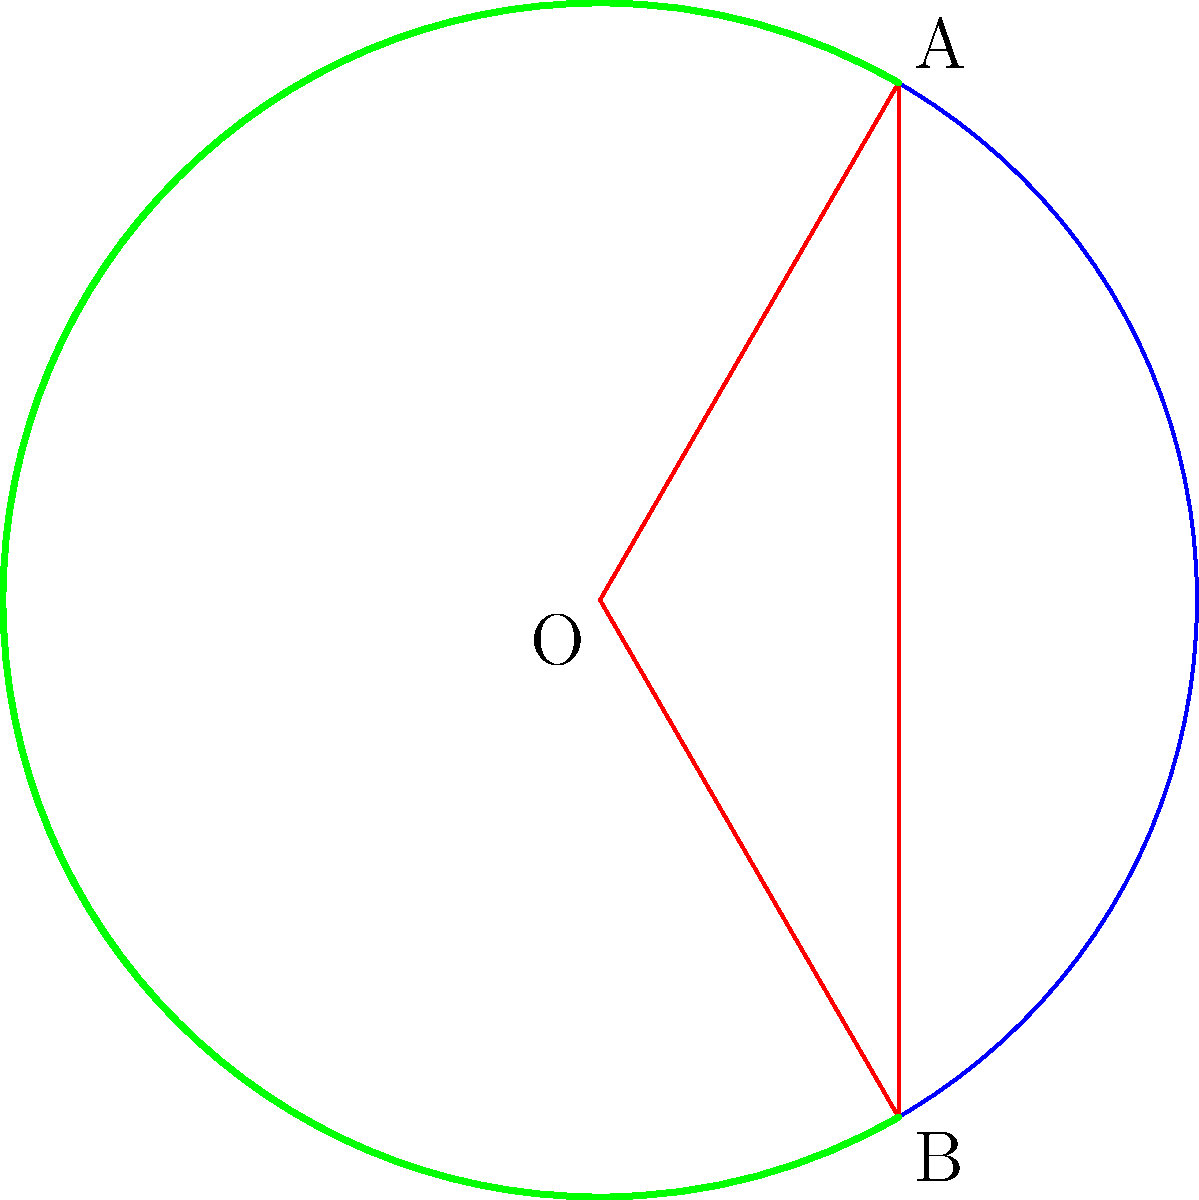In early periodic tables, elements were often arranged in circular segments. Consider a circular representation where a segment spans an angle of 120°. If the radius of the circle is 10 cm, what is the area of this segment in square centimeters? Round your answer to two decimal places. To find the area of a circular segment, we need to follow these steps:

1) The area of a circular segment is the difference between the area of a sector and the area of a triangle.

2) Area of sector:
   $A_{sector} = \frac{\theta}{360°} \pi r^2$
   Where $\theta$ is the central angle in degrees and $r$ is the radius.
   
   $A_{sector} = \frac{120}{360} \pi (10)^2 = \frac{1}{3} \pi 100 = \frac{100\pi}{3}$ cm²

3) Area of triangle:
   First, we need to find the length of the chord (AB):
   $AB = 2r \sin(\frac{\theta}{2}) = 2(10) \sin(60°) = 20 \sin(60°) = 20 \cdot \frac{\sqrt{3}}{2} = 10\sqrt{3}$ cm
   
   Now, the area of the triangle:
   $A_{triangle} = \frac{1}{2} r^2 \sin(\theta) = \frac{1}{2} (10)^2 \sin(120°) = 50 \cdot \frac{\sqrt{3}}{2} = 25\sqrt{3}$ cm²

4) Area of segment:
   $A_{segment} = A_{sector} - A_{triangle} = \frac{100\pi}{3} - 25\sqrt{3}$ cm²

5) Calculate and round to two decimal places:
   $A_{segment} \approx 104.72 - 43.30 = 61.42$ cm²
Answer: 61.42 cm² 